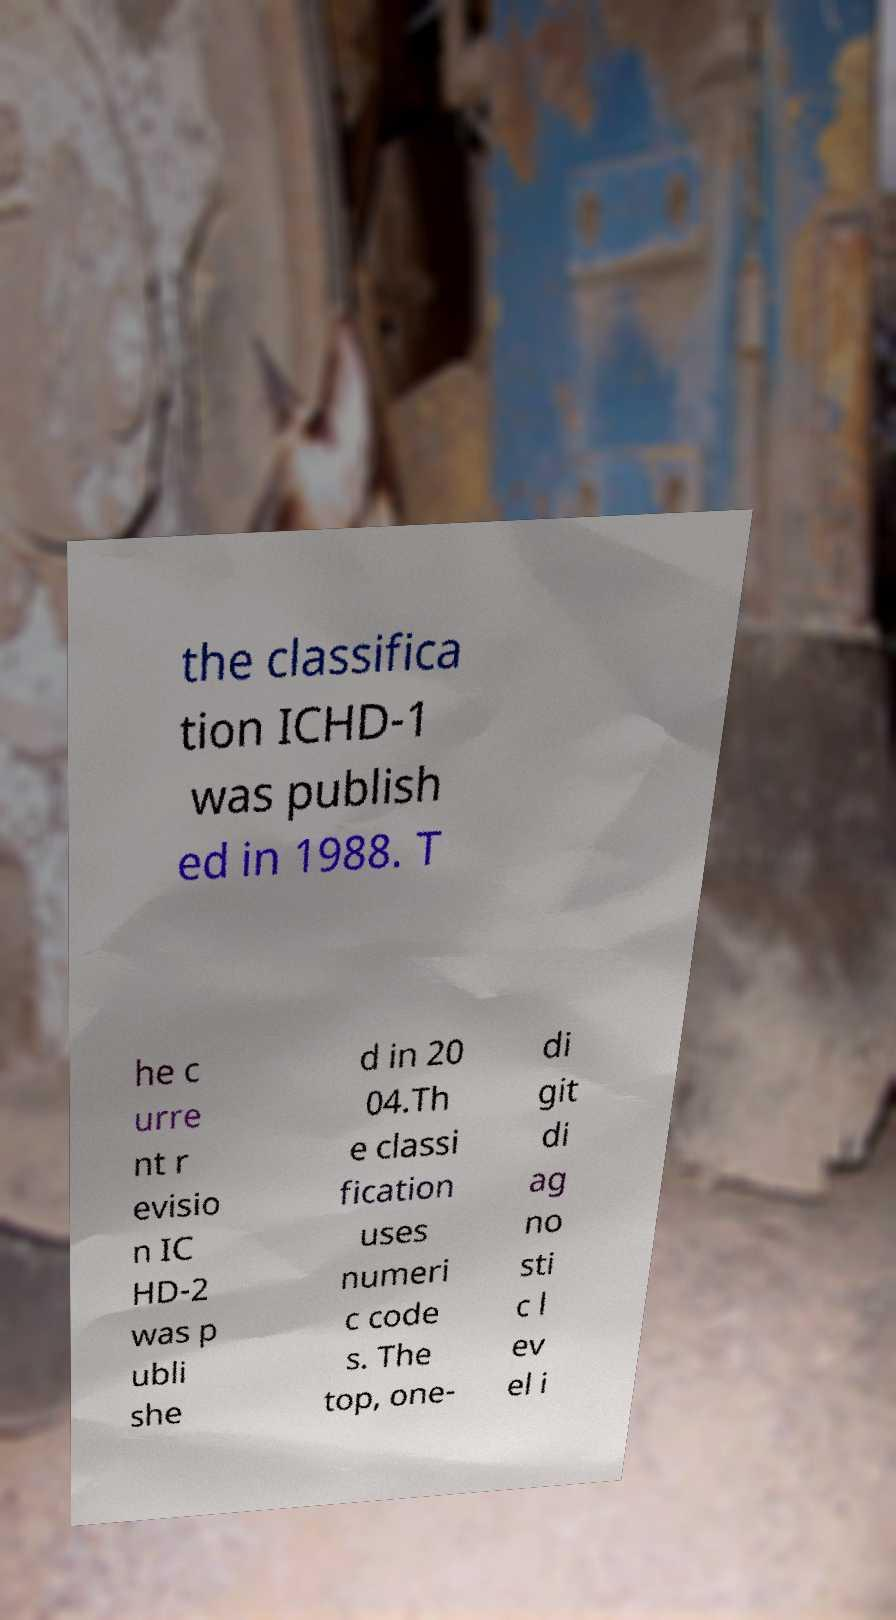Please identify and transcribe the text found in this image. the classifica tion ICHD-1 was publish ed in 1988. T he c urre nt r evisio n IC HD-2 was p ubli she d in 20 04.Th e classi fication uses numeri c code s. The top, one- di git di ag no sti c l ev el i 